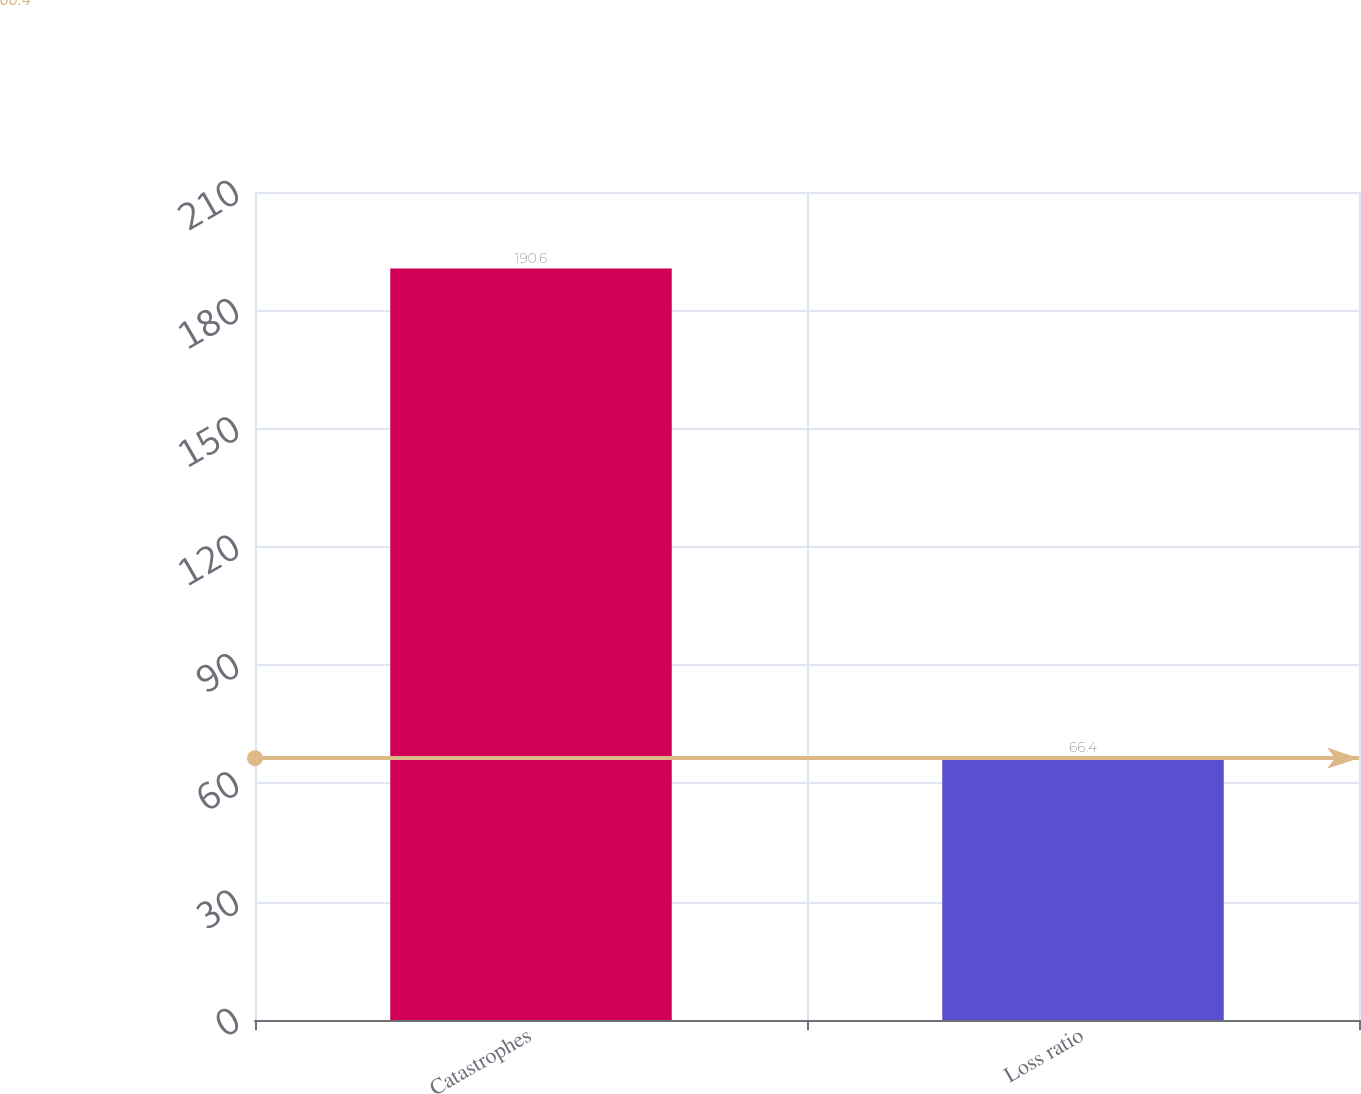Convert chart to OTSL. <chart><loc_0><loc_0><loc_500><loc_500><bar_chart><fcel>Catastrophes<fcel>Loss ratio<nl><fcel>190.6<fcel>66.4<nl></chart> 